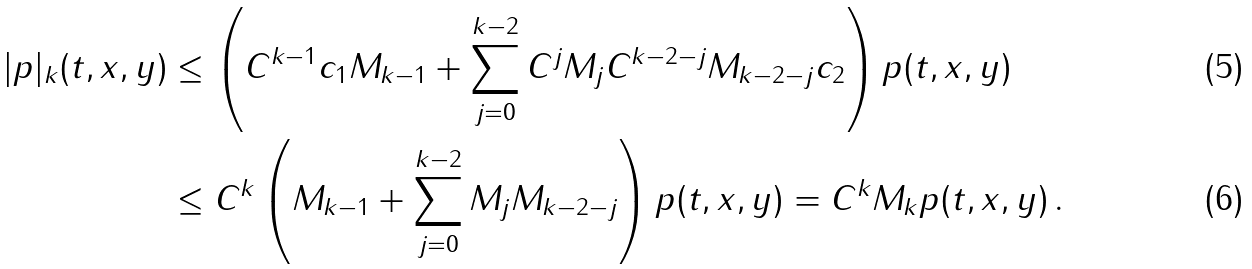<formula> <loc_0><loc_0><loc_500><loc_500>| p | _ { k } ( t , x , y ) & \leq \left ( C ^ { k - 1 } c _ { 1 } M _ { k - 1 } + \sum _ { j = 0 } ^ { k - 2 } C ^ { j } M _ { j } C ^ { k - 2 - j } M _ { k - 2 - j } c _ { 2 } \right ) p ( t , x , y ) \\ & \leq C ^ { k } \left ( M _ { k - 1 } + \sum _ { j = 0 } ^ { k - 2 } M _ { j } M _ { k - 2 - j } \right ) p ( t , x , y ) = C ^ { k } M _ { k } p ( t , x , y ) \, .</formula> 